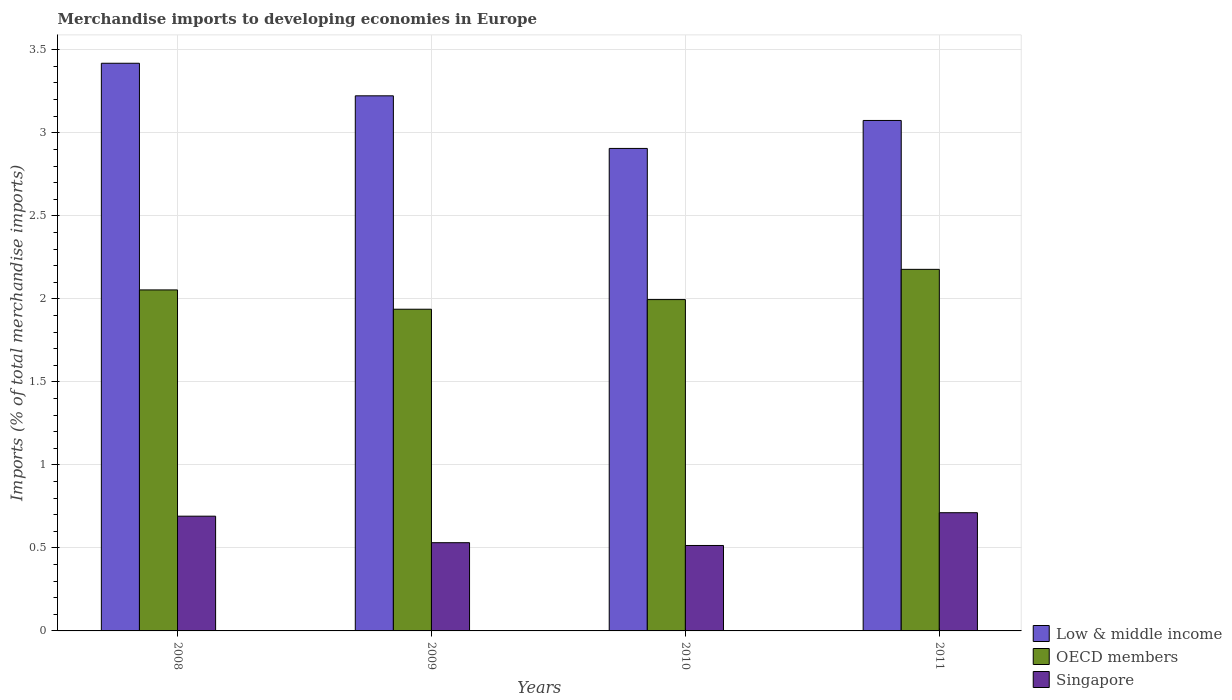How many different coloured bars are there?
Keep it short and to the point. 3. Are the number of bars per tick equal to the number of legend labels?
Ensure brevity in your answer.  Yes. Are the number of bars on each tick of the X-axis equal?
Offer a terse response. Yes. How many bars are there on the 3rd tick from the left?
Your answer should be compact. 3. How many bars are there on the 4th tick from the right?
Your response must be concise. 3. What is the label of the 2nd group of bars from the left?
Offer a terse response. 2009. What is the percentage total merchandise imports in Singapore in 2008?
Keep it short and to the point. 0.69. Across all years, what is the maximum percentage total merchandise imports in Low & middle income?
Provide a short and direct response. 3.42. Across all years, what is the minimum percentage total merchandise imports in Singapore?
Ensure brevity in your answer.  0.51. What is the total percentage total merchandise imports in Singapore in the graph?
Provide a succinct answer. 2.45. What is the difference between the percentage total merchandise imports in Singapore in 2008 and that in 2010?
Keep it short and to the point. 0.18. What is the difference between the percentage total merchandise imports in OECD members in 2011 and the percentage total merchandise imports in Singapore in 2009?
Ensure brevity in your answer.  1.65. What is the average percentage total merchandise imports in Singapore per year?
Keep it short and to the point. 0.61. In the year 2010, what is the difference between the percentage total merchandise imports in Low & middle income and percentage total merchandise imports in OECD members?
Your answer should be very brief. 0.91. In how many years, is the percentage total merchandise imports in OECD members greater than 0.4 %?
Your answer should be compact. 4. What is the ratio of the percentage total merchandise imports in Low & middle income in 2008 to that in 2010?
Your answer should be very brief. 1.18. Is the percentage total merchandise imports in Singapore in 2008 less than that in 2011?
Your response must be concise. Yes. What is the difference between the highest and the second highest percentage total merchandise imports in Singapore?
Your answer should be compact. 0.02. What is the difference between the highest and the lowest percentage total merchandise imports in Low & middle income?
Give a very brief answer. 0.51. What does the 3rd bar from the left in 2011 represents?
Give a very brief answer. Singapore. What does the 1st bar from the right in 2010 represents?
Your answer should be very brief. Singapore. Are all the bars in the graph horizontal?
Your answer should be compact. No. What is the difference between two consecutive major ticks on the Y-axis?
Keep it short and to the point. 0.5. Does the graph contain any zero values?
Give a very brief answer. No. Where does the legend appear in the graph?
Your answer should be compact. Bottom right. How many legend labels are there?
Make the answer very short. 3. How are the legend labels stacked?
Ensure brevity in your answer.  Vertical. What is the title of the graph?
Your answer should be compact. Merchandise imports to developing economies in Europe. What is the label or title of the X-axis?
Your response must be concise. Years. What is the label or title of the Y-axis?
Your answer should be very brief. Imports (% of total merchandise imports). What is the Imports (% of total merchandise imports) of Low & middle income in 2008?
Provide a succinct answer. 3.42. What is the Imports (% of total merchandise imports) in OECD members in 2008?
Make the answer very short. 2.05. What is the Imports (% of total merchandise imports) of Singapore in 2008?
Your answer should be very brief. 0.69. What is the Imports (% of total merchandise imports) in Low & middle income in 2009?
Keep it short and to the point. 3.22. What is the Imports (% of total merchandise imports) in OECD members in 2009?
Provide a short and direct response. 1.94. What is the Imports (% of total merchandise imports) in Singapore in 2009?
Give a very brief answer. 0.53. What is the Imports (% of total merchandise imports) of Low & middle income in 2010?
Offer a terse response. 2.91. What is the Imports (% of total merchandise imports) of OECD members in 2010?
Your response must be concise. 2. What is the Imports (% of total merchandise imports) of Singapore in 2010?
Offer a very short reply. 0.51. What is the Imports (% of total merchandise imports) in Low & middle income in 2011?
Provide a short and direct response. 3.07. What is the Imports (% of total merchandise imports) in OECD members in 2011?
Provide a succinct answer. 2.18. What is the Imports (% of total merchandise imports) in Singapore in 2011?
Make the answer very short. 0.71. Across all years, what is the maximum Imports (% of total merchandise imports) in Low & middle income?
Provide a succinct answer. 3.42. Across all years, what is the maximum Imports (% of total merchandise imports) of OECD members?
Your response must be concise. 2.18. Across all years, what is the maximum Imports (% of total merchandise imports) of Singapore?
Ensure brevity in your answer.  0.71. Across all years, what is the minimum Imports (% of total merchandise imports) in Low & middle income?
Make the answer very short. 2.91. Across all years, what is the minimum Imports (% of total merchandise imports) of OECD members?
Offer a very short reply. 1.94. Across all years, what is the minimum Imports (% of total merchandise imports) in Singapore?
Provide a short and direct response. 0.51. What is the total Imports (% of total merchandise imports) of Low & middle income in the graph?
Keep it short and to the point. 12.62. What is the total Imports (% of total merchandise imports) in OECD members in the graph?
Provide a short and direct response. 8.16. What is the total Imports (% of total merchandise imports) of Singapore in the graph?
Give a very brief answer. 2.45. What is the difference between the Imports (% of total merchandise imports) in Low & middle income in 2008 and that in 2009?
Offer a terse response. 0.2. What is the difference between the Imports (% of total merchandise imports) of OECD members in 2008 and that in 2009?
Ensure brevity in your answer.  0.12. What is the difference between the Imports (% of total merchandise imports) in Singapore in 2008 and that in 2009?
Provide a short and direct response. 0.16. What is the difference between the Imports (% of total merchandise imports) in Low & middle income in 2008 and that in 2010?
Provide a succinct answer. 0.51. What is the difference between the Imports (% of total merchandise imports) of OECD members in 2008 and that in 2010?
Keep it short and to the point. 0.06. What is the difference between the Imports (% of total merchandise imports) of Singapore in 2008 and that in 2010?
Your answer should be very brief. 0.18. What is the difference between the Imports (% of total merchandise imports) of Low & middle income in 2008 and that in 2011?
Your answer should be compact. 0.34. What is the difference between the Imports (% of total merchandise imports) of OECD members in 2008 and that in 2011?
Your response must be concise. -0.12. What is the difference between the Imports (% of total merchandise imports) of Singapore in 2008 and that in 2011?
Your response must be concise. -0.02. What is the difference between the Imports (% of total merchandise imports) in Low & middle income in 2009 and that in 2010?
Offer a terse response. 0.32. What is the difference between the Imports (% of total merchandise imports) in OECD members in 2009 and that in 2010?
Your response must be concise. -0.06. What is the difference between the Imports (% of total merchandise imports) of Singapore in 2009 and that in 2010?
Provide a short and direct response. 0.02. What is the difference between the Imports (% of total merchandise imports) of Low & middle income in 2009 and that in 2011?
Provide a short and direct response. 0.15. What is the difference between the Imports (% of total merchandise imports) in OECD members in 2009 and that in 2011?
Provide a short and direct response. -0.24. What is the difference between the Imports (% of total merchandise imports) of Singapore in 2009 and that in 2011?
Offer a terse response. -0.18. What is the difference between the Imports (% of total merchandise imports) in Low & middle income in 2010 and that in 2011?
Provide a succinct answer. -0.17. What is the difference between the Imports (% of total merchandise imports) of OECD members in 2010 and that in 2011?
Offer a very short reply. -0.18. What is the difference between the Imports (% of total merchandise imports) in Singapore in 2010 and that in 2011?
Make the answer very short. -0.2. What is the difference between the Imports (% of total merchandise imports) of Low & middle income in 2008 and the Imports (% of total merchandise imports) of OECD members in 2009?
Make the answer very short. 1.48. What is the difference between the Imports (% of total merchandise imports) of Low & middle income in 2008 and the Imports (% of total merchandise imports) of Singapore in 2009?
Offer a very short reply. 2.89. What is the difference between the Imports (% of total merchandise imports) in OECD members in 2008 and the Imports (% of total merchandise imports) in Singapore in 2009?
Offer a terse response. 1.52. What is the difference between the Imports (% of total merchandise imports) of Low & middle income in 2008 and the Imports (% of total merchandise imports) of OECD members in 2010?
Your answer should be compact. 1.42. What is the difference between the Imports (% of total merchandise imports) of Low & middle income in 2008 and the Imports (% of total merchandise imports) of Singapore in 2010?
Keep it short and to the point. 2.9. What is the difference between the Imports (% of total merchandise imports) of OECD members in 2008 and the Imports (% of total merchandise imports) of Singapore in 2010?
Offer a terse response. 1.54. What is the difference between the Imports (% of total merchandise imports) in Low & middle income in 2008 and the Imports (% of total merchandise imports) in OECD members in 2011?
Ensure brevity in your answer.  1.24. What is the difference between the Imports (% of total merchandise imports) of Low & middle income in 2008 and the Imports (% of total merchandise imports) of Singapore in 2011?
Your answer should be compact. 2.71. What is the difference between the Imports (% of total merchandise imports) in OECD members in 2008 and the Imports (% of total merchandise imports) in Singapore in 2011?
Your answer should be compact. 1.34. What is the difference between the Imports (% of total merchandise imports) in Low & middle income in 2009 and the Imports (% of total merchandise imports) in OECD members in 2010?
Your response must be concise. 1.23. What is the difference between the Imports (% of total merchandise imports) of Low & middle income in 2009 and the Imports (% of total merchandise imports) of Singapore in 2010?
Make the answer very short. 2.71. What is the difference between the Imports (% of total merchandise imports) in OECD members in 2009 and the Imports (% of total merchandise imports) in Singapore in 2010?
Give a very brief answer. 1.42. What is the difference between the Imports (% of total merchandise imports) in Low & middle income in 2009 and the Imports (% of total merchandise imports) in OECD members in 2011?
Your answer should be compact. 1.05. What is the difference between the Imports (% of total merchandise imports) in Low & middle income in 2009 and the Imports (% of total merchandise imports) in Singapore in 2011?
Provide a short and direct response. 2.51. What is the difference between the Imports (% of total merchandise imports) in OECD members in 2009 and the Imports (% of total merchandise imports) in Singapore in 2011?
Your answer should be compact. 1.23. What is the difference between the Imports (% of total merchandise imports) of Low & middle income in 2010 and the Imports (% of total merchandise imports) of OECD members in 2011?
Provide a succinct answer. 0.73. What is the difference between the Imports (% of total merchandise imports) in Low & middle income in 2010 and the Imports (% of total merchandise imports) in Singapore in 2011?
Offer a very short reply. 2.19. What is the difference between the Imports (% of total merchandise imports) of OECD members in 2010 and the Imports (% of total merchandise imports) of Singapore in 2011?
Your response must be concise. 1.28. What is the average Imports (% of total merchandise imports) of Low & middle income per year?
Make the answer very short. 3.16. What is the average Imports (% of total merchandise imports) in OECD members per year?
Provide a succinct answer. 2.04. What is the average Imports (% of total merchandise imports) in Singapore per year?
Your answer should be very brief. 0.61. In the year 2008, what is the difference between the Imports (% of total merchandise imports) in Low & middle income and Imports (% of total merchandise imports) in OECD members?
Offer a very short reply. 1.37. In the year 2008, what is the difference between the Imports (% of total merchandise imports) in Low & middle income and Imports (% of total merchandise imports) in Singapore?
Offer a very short reply. 2.73. In the year 2008, what is the difference between the Imports (% of total merchandise imports) of OECD members and Imports (% of total merchandise imports) of Singapore?
Your response must be concise. 1.36. In the year 2009, what is the difference between the Imports (% of total merchandise imports) of Low & middle income and Imports (% of total merchandise imports) of OECD members?
Offer a terse response. 1.29. In the year 2009, what is the difference between the Imports (% of total merchandise imports) of Low & middle income and Imports (% of total merchandise imports) of Singapore?
Make the answer very short. 2.69. In the year 2009, what is the difference between the Imports (% of total merchandise imports) in OECD members and Imports (% of total merchandise imports) in Singapore?
Your answer should be compact. 1.41. In the year 2010, what is the difference between the Imports (% of total merchandise imports) of Low & middle income and Imports (% of total merchandise imports) of OECD members?
Give a very brief answer. 0.91. In the year 2010, what is the difference between the Imports (% of total merchandise imports) of Low & middle income and Imports (% of total merchandise imports) of Singapore?
Make the answer very short. 2.39. In the year 2010, what is the difference between the Imports (% of total merchandise imports) of OECD members and Imports (% of total merchandise imports) of Singapore?
Provide a short and direct response. 1.48. In the year 2011, what is the difference between the Imports (% of total merchandise imports) of Low & middle income and Imports (% of total merchandise imports) of OECD members?
Your answer should be very brief. 0.9. In the year 2011, what is the difference between the Imports (% of total merchandise imports) in Low & middle income and Imports (% of total merchandise imports) in Singapore?
Provide a short and direct response. 2.36. In the year 2011, what is the difference between the Imports (% of total merchandise imports) of OECD members and Imports (% of total merchandise imports) of Singapore?
Provide a short and direct response. 1.47. What is the ratio of the Imports (% of total merchandise imports) in Low & middle income in 2008 to that in 2009?
Ensure brevity in your answer.  1.06. What is the ratio of the Imports (% of total merchandise imports) in OECD members in 2008 to that in 2009?
Offer a very short reply. 1.06. What is the ratio of the Imports (% of total merchandise imports) in Singapore in 2008 to that in 2009?
Your answer should be compact. 1.3. What is the ratio of the Imports (% of total merchandise imports) of Low & middle income in 2008 to that in 2010?
Offer a terse response. 1.18. What is the ratio of the Imports (% of total merchandise imports) of OECD members in 2008 to that in 2010?
Keep it short and to the point. 1.03. What is the ratio of the Imports (% of total merchandise imports) of Singapore in 2008 to that in 2010?
Your answer should be very brief. 1.34. What is the ratio of the Imports (% of total merchandise imports) in Low & middle income in 2008 to that in 2011?
Your answer should be very brief. 1.11. What is the ratio of the Imports (% of total merchandise imports) in OECD members in 2008 to that in 2011?
Give a very brief answer. 0.94. What is the ratio of the Imports (% of total merchandise imports) of Singapore in 2008 to that in 2011?
Provide a short and direct response. 0.97. What is the ratio of the Imports (% of total merchandise imports) in Low & middle income in 2009 to that in 2010?
Offer a terse response. 1.11. What is the ratio of the Imports (% of total merchandise imports) of OECD members in 2009 to that in 2010?
Your answer should be very brief. 0.97. What is the ratio of the Imports (% of total merchandise imports) in Singapore in 2009 to that in 2010?
Your answer should be compact. 1.03. What is the ratio of the Imports (% of total merchandise imports) of Low & middle income in 2009 to that in 2011?
Provide a short and direct response. 1.05. What is the ratio of the Imports (% of total merchandise imports) of OECD members in 2009 to that in 2011?
Provide a short and direct response. 0.89. What is the ratio of the Imports (% of total merchandise imports) in Singapore in 2009 to that in 2011?
Give a very brief answer. 0.75. What is the ratio of the Imports (% of total merchandise imports) in Low & middle income in 2010 to that in 2011?
Offer a terse response. 0.95. What is the ratio of the Imports (% of total merchandise imports) in OECD members in 2010 to that in 2011?
Offer a terse response. 0.92. What is the ratio of the Imports (% of total merchandise imports) of Singapore in 2010 to that in 2011?
Give a very brief answer. 0.72. What is the difference between the highest and the second highest Imports (% of total merchandise imports) of Low & middle income?
Keep it short and to the point. 0.2. What is the difference between the highest and the second highest Imports (% of total merchandise imports) of OECD members?
Offer a very short reply. 0.12. What is the difference between the highest and the second highest Imports (% of total merchandise imports) in Singapore?
Give a very brief answer. 0.02. What is the difference between the highest and the lowest Imports (% of total merchandise imports) in Low & middle income?
Give a very brief answer. 0.51. What is the difference between the highest and the lowest Imports (% of total merchandise imports) in OECD members?
Provide a succinct answer. 0.24. What is the difference between the highest and the lowest Imports (% of total merchandise imports) of Singapore?
Your response must be concise. 0.2. 